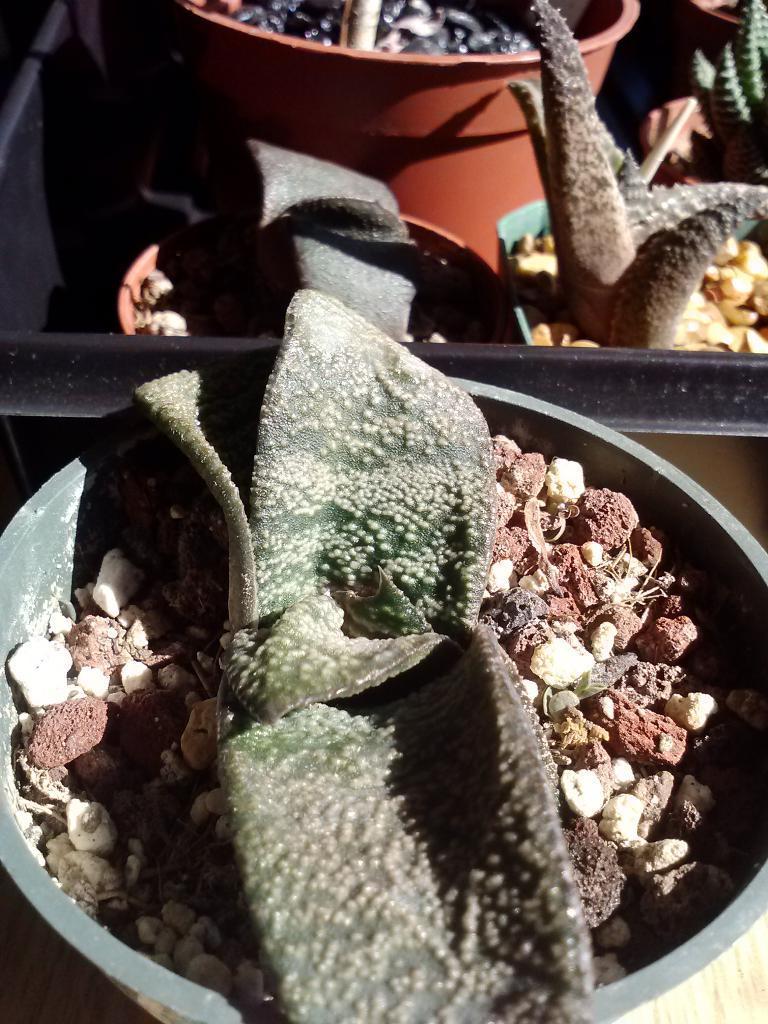Describe this image in one or two sentences. In this picture there are spots filled with the plants and stones. 